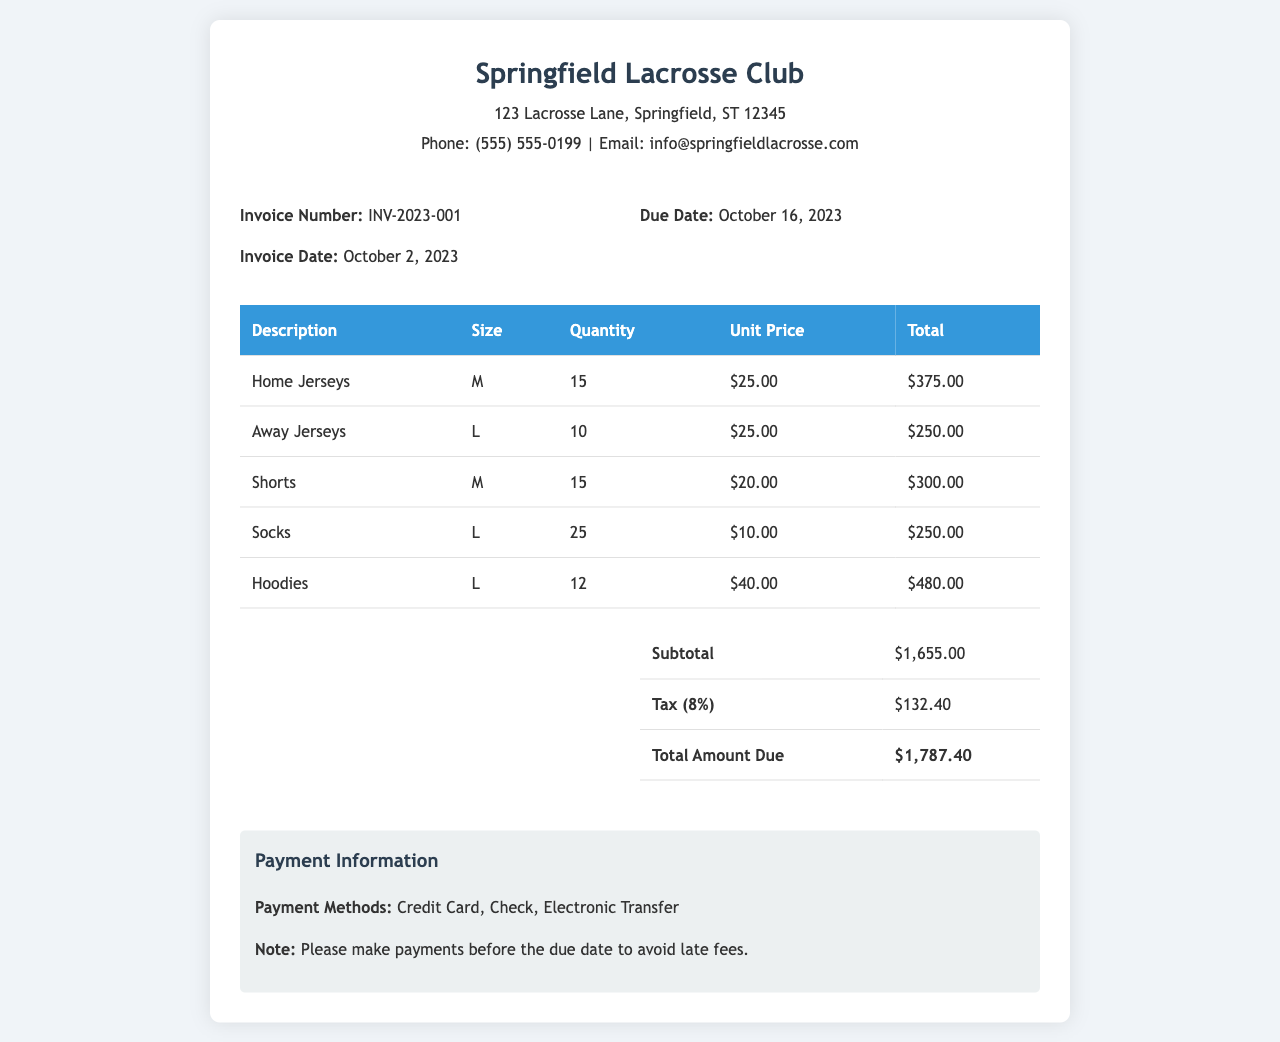What is the invoice number? The invoice number is listed in the invoice details section.
Answer: INV-2023-001 What is the total amount due? The total amount due is found in the summary table at the bottom of the invoice.
Answer: $1,787.40 How many Home Jerseys were ordered? The quantity of Home Jerseys is specified in the table of items ordered.
Answer: 15 What is the unit price for Shorts? The unit price for Shorts is stated in the corresponding row of the invoice table.
Answer: $20.00 When is the due date for this invoice? The due date is provided in the invoice details section.
Answer: October 16, 2023 What is the tax rate applied to the invoice? The tax rate is indicated alongside the tax amount in the summary table.
Answer: 8% How many total items are included in the order? The total items can be calculated by summing the quantities listed in the invoice table.
Answer: 75 What payment methods are accepted? Accepted payment methods are listed in the payment information section of the invoice.
Answer: Credit Card, Check, Electronic Transfer What is the subtotal amount before tax? The subtotal amount is shown in the summary table prior to the tax calculation.
Answer: $1,655.00 